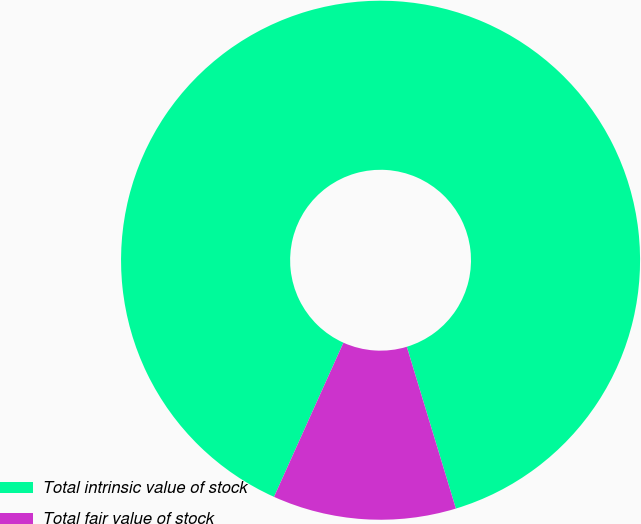Convert chart to OTSL. <chart><loc_0><loc_0><loc_500><loc_500><pie_chart><fcel>Total intrinsic value of stock<fcel>Total fair value of stock<nl><fcel>88.58%<fcel>11.42%<nl></chart> 